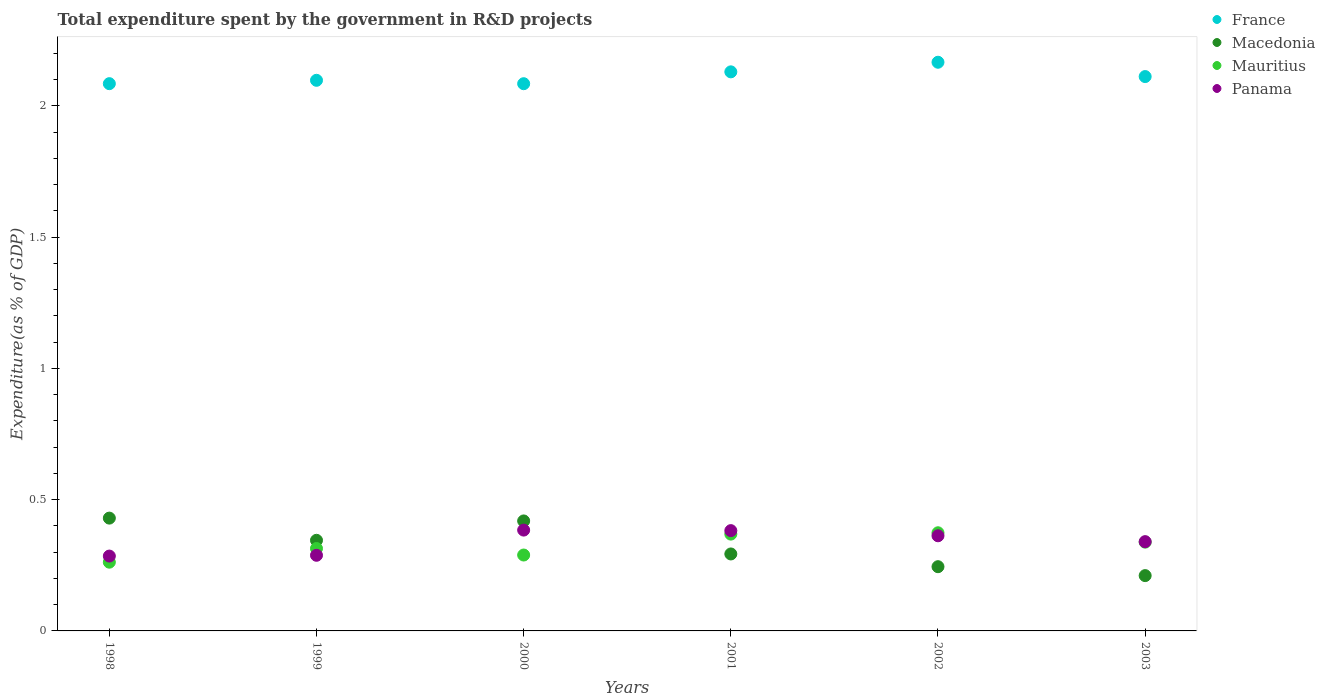How many different coloured dotlines are there?
Provide a short and direct response. 4. Is the number of dotlines equal to the number of legend labels?
Offer a terse response. Yes. What is the total expenditure spent by the government in R&D projects in Macedonia in 1999?
Provide a succinct answer. 0.35. Across all years, what is the maximum total expenditure spent by the government in R&D projects in France?
Give a very brief answer. 2.17. Across all years, what is the minimum total expenditure spent by the government in R&D projects in Panama?
Offer a very short reply. 0.29. What is the total total expenditure spent by the government in R&D projects in Panama in the graph?
Your response must be concise. 2.04. What is the difference between the total expenditure spent by the government in R&D projects in Mauritius in 2000 and that in 2001?
Keep it short and to the point. -0.08. What is the difference between the total expenditure spent by the government in R&D projects in Macedonia in 1998 and the total expenditure spent by the government in R&D projects in Panama in 2000?
Provide a short and direct response. 0.05. What is the average total expenditure spent by the government in R&D projects in France per year?
Your answer should be very brief. 2.11. In the year 2000, what is the difference between the total expenditure spent by the government in R&D projects in France and total expenditure spent by the government in R&D projects in Macedonia?
Keep it short and to the point. 1.67. In how many years, is the total expenditure spent by the government in R&D projects in France greater than 0.30000000000000004 %?
Keep it short and to the point. 6. What is the ratio of the total expenditure spent by the government in R&D projects in France in 1999 to that in 2000?
Your answer should be very brief. 1.01. Is the difference between the total expenditure spent by the government in R&D projects in France in 1999 and 2002 greater than the difference between the total expenditure spent by the government in R&D projects in Macedonia in 1999 and 2002?
Keep it short and to the point. No. What is the difference between the highest and the second highest total expenditure spent by the government in R&D projects in Macedonia?
Your answer should be very brief. 0.01. What is the difference between the highest and the lowest total expenditure spent by the government in R&D projects in Panama?
Make the answer very short. 0.1. In how many years, is the total expenditure spent by the government in R&D projects in Mauritius greater than the average total expenditure spent by the government in R&D projects in Mauritius taken over all years?
Your answer should be compact. 3. Is it the case that in every year, the sum of the total expenditure spent by the government in R&D projects in Macedonia and total expenditure spent by the government in R&D projects in Mauritius  is greater than the sum of total expenditure spent by the government in R&D projects in France and total expenditure spent by the government in R&D projects in Panama?
Make the answer very short. No. Is it the case that in every year, the sum of the total expenditure spent by the government in R&D projects in Mauritius and total expenditure spent by the government in R&D projects in Macedonia  is greater than the total expenditure spent by the government in R&D projects in Panama?
Give a very brief answer. Yes. Is the total expenditure spent by the government in R&D projects in France strictly greater than the total expenditure spent by the government in R&D projects in Panama over the years?
Ensure brevity in your answer.  Yes. How many years are there in the graph?
Your answer should be very brief. 6. Does the graph contain any zero values?
Make the answer very short. No. Does the graph contain grids?
Provide a succinct answer. No. Where does the legend appear in the graph?
Provide a succinct answer. Top right. How many legend labels are there?
Make the answer very short. 4. How are the legend labels stacked?
Ensure brevity in your answer.  Vertical. What is the title of the graph?
Make the answer very short. Total expenditure spent by the government in R&D projects. What is the label or title of the Y-axis?
Ensure brevity in your answer.  Expenditure(as % of GDP). What is the Expenditure(as % of GDP) of France in 1998?
Your response must be concise. 2.08. What is the Expenditure(as % of GDP) of Macedonia in 1998?
Your answer should be very brief. 0.43. What is the Expenditure(as % of GDP) in Mauritius in 1998?
Offer a very short reply. 0.26. What is the Expenditure(as % of GDP) of Panama in 1998?
Give a very brief answer. 0.29. What is the Expenditure(as % of GDP) in France in 1999?
Provide a succinct answer. 2.1. What is the Expenditure(as % of GDP) of Macedonia in 1999?
Your answer should be very brief. 0.35. What is the Expenditure(as % of GDP) of Mauritius in 1999?
Your answer should be very brief. 0.31. What is the Expenditure(as % of GDP) of Panama in 1999?
Offer a very short reply. 0.29. What is the Expenditure(as % of GDP) in France in 2000?
Your response must be concise. 2.08. What is the Expenditure(as % of GDP) of Macedonia in 2000?
Provide a succinct answer. 0.42. What is the Expenditure(as % of GDP) in Mauritius in 2000?
Provide a short and direct response. 0.29. What is the Expenditure(as % of GDP) in Panama in 2000?
Ensure brevity in your answer.  0.38. What is the Expenditure(as % of GDP) in France in 2001?
Your answer should be very brief. 2.13. What is the Expenditure(as % of GDP) in Macedonia in 2001?
Provide a succinct answer. 0.29. What is the Expenditure(as % of GDP) of Mauritius in 2001?
Your answer should be very brief. 0.37. What is the Expenditure(as % of GDP) in Panama in 2001?
Keep it short and to the point. 0.38. What is the Expenditure(as % of GDP) in France in 2002?
Provide a short and direct response. 2.17. What is the Expenditure(as % of GDP) of Macedonia in 2002?
Your response must be concise. 0.24. What is the Expenditure(as % of GDP) in Mauritius in 2002?
Ensure brevity in your answer.  0.37. What is the Expenditure(as % of GDP) of Panama in 2002?
Ensure brevity in your answer.  0.36. What is the Expenditure(as % of GDP) in France in 2003?
Give a very brief answer. 2.11. What is the Expenditure(as % of GDP) of Macedonia in 2003?
Your answer should be compact. 0.21. What is the Expenditure(as % of GDP) of Mauritius in 2003?
Provide a short and direct response. 0.34. What is the Expenditure(as % of GDP) in Panama in 2003?
Offer a terse response. 0.34. Across all years, what is the maximum Expenditure(as % of GDP) of France?
Your answer should be very brief. 2.17. Across all years, what is the maximum Expenditure(as % of GDP) in Macedonia?
Your response must be concise. 0.43. Across all years, what is the maximum Expenditure(as % of GDP) in Mauritius?
Your answer should be very brief. 0.37. Across all years, what is the maximum Expenditure(as % of GDP) of Panama?
Give a very brief answer. 0.38. Across all years, what is the minimum Expenditure(as % of GDP) of France?
Your response must be concise. 2.08. Across all years, what is the minimum Expenditure(as % of GDP) of Macedonia?
Provide a succinct answer. 0.21. Across all years, what is the minimum Expenditure(as % of GDP) in Mauritius?
Provide a short and direct response. 0.26. Across all years, what is the minimum Expenditure(as % of GDP) in Panama?
Keep it short and to the point. 0.29. What is the total Expenditure(as % of GDP) in France in the graph?
Provide a short and direct response. 12.67. What is the total Expenditure(as % of GDP) of Macedonia in the graph?
Give a very brief answer. 1.94. What is the total Expenditure(as % of GDP) of Mauritius in the graph?
Offer a very short reply. 1.95. What is the total Expenditure(as % of GDP) in Panama in the graph?
Provide a short and direct response. 2.04. What is the difference between the Expenditure(as % of GDP) in France in 1998 and that in 1999?
Your response must be concise. -0.01. What is the difference between the Expenditure(as % of GDP) in Macedonia in 1998 and that in 1999?
Your response must be concise. 0.08. What is the difference between the Expenditure(as % of GDP) in Mauritius in 1998 and that in 1999?
Your answer should be very brief. -0.05. What is the difference between the Expenditure(as % of GDP) of Panama in 1998 and that in 1999?
Ensure brevity in your answer.  -0. What is the difference between the Expenditure(as % of GDP) of France in 1998 and that in 2000?
Ensure brevity in your answer.  0. What is the difference between the Expenditure(as % of GDP) in Macedonia in 1998 and that in 2000?
Make the answer very short. 0.01. What is the difference between the Expenditure(as % of GDP) in Mauritius in 1998 and that in 2000?
Keep it short and to the point. -0.03. What is the difference between the Expenditure(as % of GDP) in Panama in 1998 and that in 2000?
Keep it short and to the point. -0.1. What is the difference between the Expenditure(as % of GDP) of France in 1998 and that in 2001?
Provide a short and direct response. -0.04. What is the difference between the Expenditure(as % of GDP) in Macedonia in 1998 and that in 2001?
Make the answer very short. 0.14. What is the difference between the Expenditure(as % of GDP) of Mauritius in 1998 and that in 2001?
Your answer should be very brief. -0.11. What is the difference between the Expenditure(as % of GDP) in Panama in 1998 and that in 2001?
Ensure brevity in your answer.  -0.1. What is the difference between the Expenditure(as % of GDP) of France in 1998 and that in 2002?
Provide a succinct answer. -0.08. What is the difference between the Expenditure(as % of GDP) in Macedonia in 1998 and that in 2002?
Your answer should be very brief. 0.18. What is the difference between the Expenditure(as % of GDP) in Mauritius in 1998 and that in 2002?
Offer a very short reply. -0.11. What is the difference between the Expenditure(as % of GDP) in Panama in 1998 and that in 2002?
Your response must be concise. -0.08. What is the difference between the Expenditure(as % of GDP) in France in 1998 and that in 2003?
Provide a short and direct response. -0.03. What is the difference between the Expenditure(as % of GDP) in Macedonia in 1998 and that in 2003?
Your answer should be very brief. 0.22. What is the difference between the Expenditure(as % of GDP) of Mauritius in 1998 and that in 2003?
Your response must be concise. -0.08. What is the difference between the Expenditure(as % of GDP) of Panama in 1998 and that in 2003?
Give a very brief answer. -0.05. What is the difference between the Expenditure(as % of GDP) in France in 1999 and that in 2000?
Your response must be concise. 0.01. What is the difference between the Expenditure(as % of GDP) of Macedonia in 1999 and that in 2000?
Give a very brief answer. -0.07. What is the difference between the Expenditure(as % of GDP) in Mauritius in 1999 and that in 2000?
Your answer should be compact. 0.02. What is the difference between the Expenditure(as % of GDP) of Panama in 1999 and that in 2000?
Keep it short and to the point. -0.1. What is the difference between the Expenditure(as % of GDP) in France in 1999 and that in 2001?
Your answer should be compact. -0.03. What is the difference between the Expenditure(as % of GDP) in Macedonia in 1999 and that in 2001?
Your response must be concise. 0.05. What is the difference between the Expenditure(as % of GDP) of Mauritius in 1999 and that in 2001?
Provide a short and direct response. -0.05. What is the difference between the Expenditure(as % of GDP) in Panama in 1999 and that in 2001?
Keep it short and to the point. -0.09. What is the difference between the Expenditure(as % of GDP) in France in 1999 and that in 2002?
Give a very brief answer. -0.07. What is the difference between the Expenditure(as % of GDP) of Macedonia in 1999 and that in 2002?
Your response must be concise. 0.1. What is the difference between the Expenditure(as % of GDP) in Mauritius in 1999 and that in 2002?
Give a very brief answer. -0.06. What is the difference between the Expenditure(as % of GDP) of Panama in 1999 and that in 2002?
Offer a terse response. -0.07. What is the difference between the Expenditure(as % of GDP) in France in 1999 and that in 2003?
Provide a succinct answer. -0.01. What is the difference between the Expenditure(as % of GDP) of Macedonia in 1999 and that in 2003?
Ensure brevity in your answer.  0.13. What is the difference between the Expenditure(as % of GDP) of Mauritius in 1999 and that in 2003?
Your answer should be very brief. -0.02. What is the difference between the Expenditure(as % of GDP) of Panama in 1999 and that in 2003?
Make the answer very short. -0.05. What is the difference between the Expenditure(as % of GDP) in France in 2000 and that in 2001?
Provide a succinct answer. -0.05. What is the difference between the Expenditure(as % of GDP) of Macedonia in 2000 and that in 2001?
Ensure brevity in your answer.  0.13. What is the difference between the Expenditure(as % of GDP) of Mauritius in 2000 and that in 2001?
Make the answer very short. -0.08. What is the difference between the Expenditure(as % of GDP) of Panama in 2000 and that in 2001?
Provide a succinct answer. 0. What is the difference between the Expenditure(as % of GDP) of France in 2000 and that in 2002?
Your answer should be very brief. -0.08. What is the difference between the Expenditure(as % of GDP) of Macedonia in 2000 and that in 2002?
Provide a succinct answer. 0.17. What is the difference between the Expenditure(as % of GDP) in Mauritius in 2000 and that in 2002?
Your answer should be very brief. -0.08. What is the difference between the Expenditure(as % of GDP) in Panama in 2000 and that in 2002?
Offer a very short reply. 0.02. What is the difference between the Expenditure(as % of GDP) of France in 2000 and that in 2003?
Offer a terse response. -0.03. What is the difference between the Expenditure(as % of GDP) of Macedonia in 2000 and that in 2003?
Your response must be concise. 0.21. What is the difference between the Expenditure(as % of GDP) of Mauritius in 2000 and that in 2003?
Give a very brief answer. -0.05. What is the difference between the Expenditure(as % of GDP) of Panama in 2000 and that in 2003?
Ensure brevity in your answer.  0.04. What is the difference between the Expenditure(as % of GDP) of France in 2001 and that in 2002?
Provide a short and direct response. -0.04. What is the difference between the Expenditure(as % of GDP) in Macedonia in 2001 and that in 2002?
Offer a very short reply. 0.05. What is the difference between the Expenditure(as % of GDP) of Mauritius in 2001 and that in 2002?
Offer a very short reply. -0.01. What is the difference between the Expenditure(as % of GDP) of Panama in 2001 and that in 2002?
Your answer should be compact. 0.02. What is the difference between the Expenditure(as % of GDP) in France in 2001 and that in 2003?
Give a very brief answer. 0.02. What is the difference between the Expenditure(as % of GDP) of Macedonia in 2001 and that in 2003?
Provide a succinct answer. 0.08. What is the difference between the Expenditure(as % of GDP) of Mauritius in 2001 and that in 2003?
Offer a terse response. 0.03. What is the difference between the Expenditure(as % of GDP) of Panama in 2001 and that in 2003?
Provide a short and direct response. 0.04. What is the difference between the Expenditure(as % of GDP) in France in 2002 and that in 2003?
Make the answer very short. 0.05. What is the difference between the Expenditure(as % of GDP) of Macedonia in 2002 and that in 2003?
Keep it short and to the point. 0.03. What is the difference between the Expenditure(as % of GDP) in Mauritius in 2002 and that in 2003?
Your answer should be very brief. 0.04. What is the difference between the Expenditure(as % of GDP) of Panama in 2002 and that in 2003?
Ensure brevity in your answer.  0.02. What is the difference between the Expenditure(as % of GDP) of France in 1998 and the Expenditure(as % of GDP) of Macedonia in 1999?
Keep it short and to the point. 1.74. What is the difference between the Expenditure(as % of GDP) of France in 1998 and the Expenditure(as % of GDP) of Mauritius in 1999?
Provide a short and direct response. 1.77. What is the difference between the Expenditure(as % of GDP) in France in 1998 and the Expenditure(as % of GDP) in Panama in 1999?
Offer a very short reply. 1.8. What is the difference between the Expenditure(as % of GDP) of Macedonia in 1998 and the Expenditure(as % of GDP) of Mauritius in 1999?
Your answer should be very brief. 0.12. What is the difference between the Expenditure(as % of GDP) in Macedonia in 1998 and the Expenditure(as % of GDP) in Panama in 1999?
Your answer should be compact. 0.14. What is the difference between the Expenditure(as % of GDP) in Mauritius in 1998 and the Expenditure(as % of GDP) in Panama in 1999?
Provide a succinct answer. -0.03. What is the difference between the Expenditure(as % of GDP) of France in 1998 and the Expenditure(as % of GDP) of Macedonia in 2000?
Keep it short and to the point. 1.67. What is the difference between the Expenditure(as % of GDP) of France in 1998 and the Expenditure(as % of GDP) of Mauritius in 2000?
Ensure brevity in your answer.  1.8. What is the difference between the Expenditure(as % of GDP) of France in 1998 and the Expenditure(as % of GDP) of Panama in 2000?
Your answer should be very brief. 1.7. What is the difference between the Expenditure(as % of GDP) of Macedonia in 1998 and the Expenditure(as % of GDP) of Mauritius in 2000?
Your response must be concise. 0.14. What is the difference between the Expenditure(as % of GDP) in Macedonia in 1998 and the Expenditure(as % of GDP) in Panama in 2000?
Your response must be concise. 0.05. What is the difference between the Expenditure(as % of GDP) in Mauritius in 1998 and the Expenditure(as % of GDP) in Panama in 2000?
Your answer should be compact. -0.12. What is the difference between the Expenditure(as % of GDP) in France in 1998 and the Expenditure(as % of GDP) in Macedonia in 2001?
Keep it short and to the point. 1.79. What is the difference between the Expenditure(as % of GDP) in France in 1998 and the Expenditure(as % of GDP) in Mauritius in 2001?
Ensure brevity in your answer.  1.72. What is the difference between the Expenditure(as % of GDP) in France in 1998 and the Expenditure(as % of GDP) in Panama in 2001?
Offer a very short reply. 1.7. What is the difference between the Expenditure(as % of GDP) of Macedonia in 1998 and the Expenditure(as % of GDP) of Mauritius in 2001?
Provide a short and direct response. 0.06. What is the difference between the Expenditure(as % of GDP) of Macedonia in 1998 and the Expenditure(as % of GDP) of Panama in 2001?
Your answer should be very brief. 0.05. What is the difference between the Expenditure(as % of GDP) of Mauritius in 1998 and the Expenditure(as % of GDP) of Panama in 2001?
Your answer should be compact. -0.12. What is the difference between the Expenditure(as % of GDP) of France in 1998 and the Expenditure(as % of GDP) of Macedonia in 2002?
Keep it short and to the point. 1.84. What is the difference between the Expenditure(as % of GDP) of France in 1998 and the Expenditure(as % of GDP) of Mauritius in 2002?
Your answer should be very brief. 1.71. What is the difference between the Expenditure(as % of GDP) in France in 1998 and the Expenditure(as % of GDP) in Panama in 2002?
Offer a very short reply. 1.72. What is the difference between the Expenditure(as % of GDP) in Macedonia in 1998 and the Expenditure(as % of GDP) in Mauritius in 2002?
Your answer should be very brief. 0.06. What is the difference between the Expenditure(as % of GDP) in Macedonia in 1998 and the Expenditure(as % of GDP) in Panama in 2002?
Provide a short and direct response. 0.07. What is the difference between the Expenditure(as % of GDP) in Mauritius in 1998 and the Expenditure(as % of GDP) in Panama in 2002?
Offer a terse response. -0.1. What is the difference between the Expenditure(as % of GDP) of France in 1998 and the Expenditure(as % of GDP) of Macedonia in 2003?
Offer a very short reply. 1.87. What is the difference between the Expenditure(as % of GDP) of France in 1998 and the Expenditure(as % of GDP) of Mauritius in 2003?
Give a very brief answer. 1.75. What is the difference between the Expenditure(as % of GDP) in France in 1998 and the Expenditure(as % of GDP) in Panama in 2003?
Provide a short and direct response. 1.74. What is the difference between the Expenditure(as % of GDP) in Macedonia in 1998 and the Expenditure(as % of GDP) in Mauritius in 2003?
Offer a terse response. 0.09. What is the difference between the Expenditure(as % of GDP) in Macedonia in 1998 and the Expenditure(as % of GDP) in Panama in 2003?
Your response must be concise. 0.09. What is the difference between the Expenditure(as % of GDP) in Mauritius in 1998 and the Expenditure(as % of GDP) in Panama in 2003?
Give a very brief answer. -0.08. What is the difference between the Expenditure(as % of GDP) in France in 1999 and the Expenditure(as % of GDP) in Macedonia in 2000?
Ensure brevity in your answer.  1.68. What is the difference between the Expenditure(as % of GDP) of France in 1999 and the Expenditure(as % of GDP) of Mauritius in 2000?
Ensure brevity in your answer.  1.81. What is the difference between the Expenditure(as % of GDP) in France in 1999 and the Expenditure(as % of GDP) in Panama in 2000?
Give a very brief answer. 1.71. What is the difference between the Expenditure(as % of GDP) of Macedonia in 1999 and the Expenditure(as % of GDP) of Mauritius in 2000?
Offer a very short reply. 0.06. What is the difference between the Expenditure(as % of GDP) in Macedonia in 1999 and the Expenditure(as % of GDP) in Panama in 2000?
Give a very brief answer. -0.04. What is the difference between the Expenditure(as % of GDP) of Mauritius in 1999 and the Expenditure(as % of GDP) of Panama in 2000?
Offer a very short reply. -0.07. What is the difference between the Expenditure(as % of GDP) of France in 1999 and the Expenditure(as % of GDP) of Macedonia in 2001?
Offer a terse response. 1.8. What is the difference between the Expenditure(as % of GDP) in France in 1999 and the Expenditure(as % of GDP) in Mauritius in 2001?
Keep it short and to the point. 1.73. What is the difference between the Expenditure(as % of GDP) in France in 1999 and the Expenditure(as % of GDP) in Panama in 2001?
Give a very brief answer. 1.72. What is the difference between the Expenditure(as % of GDP) of Macedonia in 1999 and the Expenditure(as % of GDP) of Mauritius in 2001?
Offer a terse response. -0.02. What is the difference between the Expenditure(as % of GDP) in Macedonia in 1999 and the Expenditure(as % of GDP) in Panama in 2001?
Ensure brevity in your answer.  -0.04. What is the difference between the Expenditure(as % of GDP) in Mauritius in 1999 and the Expenditure(as % of GDP) in Panama in 2001?
Give a very brief answer. -0.07. What is the difference between the Expenditure(as % of GDP) of France in 1999 and the Expenditure(as % of GDP) of Macedonia in 2002?
Your response must be concise. 1.85. What is the difference between the Expenditure(as % of GDP) in France in 1999 and the Expenditure(as % of GDP) in Mauritius in 2002?
Make the answer very short. 1.72. What is the difference between the Expenditure(as % of GDP) of France in 1999 and the Expenditure(as % of GDP) of Panama in 2002?
Your response must be concise. 1.73. What is the difference between the Expenditure(as % of GDP) of Macedonia in 1999 and the Expenditure(as % of GDP) of Mauritius in 2002?
Your response must be concise. -0.03. What is the difference between the Expenditure(as % of GDP) of Macedonia in 1999 and the Expenditure(as % of GDP) of Panama in 2002?
Your answer should be compact. -0.02. What is the difference between the Expenditure(as % of GDP) of Mauritius in 1999 and the Expenditure(as % of GDP) of Panama in 2002?
Provide a succinct answer. -0.05. What is the difference between the Expenditure(as % of GDP) in France in 1999 and the Expenditure(as % of GDP) in Macedonia in 2003?
Keep it short and to the point. 1.89. What is the difference between the Expenditure(as % of GDP) in France in 1999 and the Expenditure(as % of GDP) in Mauritius in 2003?
Give a very brief answer. 1.76. What is the difference between the Expenditure(as % of GDP) in France in 1999 and the Expenditure(as % of GDP) in Panama in 2003?
Offer a terse response. 1.76. What is the difference between the Expenditure(as % of GDP) of Macedonia in 1999 and the Expenditure(as % of GDP) of Mauritius in 2003?
Your answer should be compact. 0.01. What is the difference between the Expenditure(as % of GDP) of Macedonia in 1999 and the Expenditure(as % of GDP) of Panama in 2003?
Give a very brief answer. 0.01. What is the difference between the Expenditure(as % of GDP) in Mauritius in 1999 and the Expenditure(as % of GDP) in Panama in 2003?
Provide a succinct answer. -0.03. What is the difference between the Expenditure(as % of GDP) in France in 2000 and the Expenditure(as % of GDP) in Macedonia in 2001?
Offer a very short reply. 1.79. What is the difference between the Expenditure(as % of GDP) of France in 2000 and the Expenditure(as % of GDP) of Mauritius in 2001?
Your answer should be compact. 1.72. What is the difference between the Expenditure(as % of GDP) in France in 2000 and the Expenditure(as % of GDP) in Panama in 2001?
Give a very brief answer. 1.7. What is the difference between the Expenditure(as % of GDP) in Macedonia in 2000 and the Expenditure(as % of GDP) in Mauritius in 2001?
Provide a short and direct response. 0.05. What is the difference between the Expenditure(as % of GDP) of Macedonia in 2000 and the Expenditure(as % of GDP) of Panama in 2001?
Provide a short and direct response. 0.04. What is the difference between the Expenditure(as % of GDP) of Mauritius in 2000 and the Expenditure(as % of GDP) of Panama in 2001?
Your answer should be very brief. -0.09. What is the difference between the Expenditure(as % of GDP) in France in 2000 and the Expenditure(as % of GDP) in Macedonia in 2002?
Keep it short and to the point. 1.84. What is the difference between the Expenditure(as % of GDP) of France in 2000 and the Expenditure(as % of GDP) of Mauritius in 2002?
Ensure brevity in your answer.  1.71. What is the difference between the Expenditure(as % of GDP) of France in 2000 and the Expenditure(as % of GDP) of Panama in 2002?
Provide a short and direct response. 1.72. What is the difference between the Expenditure(as % of GDP) of Macedonia in 2000 and the Expenditure(as % of GDP) of Mauritius in 2002?
Give a very brief answer. 0.05. What is the difference between the Expenditure(as % of GDP) in Macedonia in 2000 and the Expenditure(as % of GDP) in Panama in 2002?
Keep it short and to the point. 0.06. What is the difference between the Expenditure(as % of GDP) in Mauritius in 2000 and the Expenditure(as % of GDP) in Panama in 2002?
Ensure brevity in your answer.  -0.07. What is the difference between the Expenditure(as % of GDP) in France in 2000 and the Expenditure(as % of GDP) in Macedonia in 2003?
Your answer should be very brief. 1.87. What is the difference between the Expenditure(as % of GDP) of France in 2000 and the Expenditure(as % of GDP) of Mauritius in 2003?
Offer a very short reply. 1.75. What is the difference between the Expenditure(as % of GDP) in France in 2000 and the Expenditure(as % of GDP) in Panama in 2003?
Ensure brevity in your answer.  1.74. What is the difference between the Expenditure(as % of GDP) of Macedonia in 2000 and the Expenditure(as % of GDP) of Mauritius in 2003?
Your response must be concise. 0.08. What is the difference between the Expenditure(as % of GDP) of Macedonia in 2000 and the Expenditure(as % of GDP) of Panama in 2003?
Provide a succinct answer. 0.08. What is the difference between the Expenditure(as % of GDP) of Mauritius in 2000 and the Expenditure(as % of GDP) of Panama in 2003?
Offer a very short reply. -0.05. What is the difference between the Expenditure(as % of GDP) in France in 2001 and the Expenditure(as % of GDP) in Macedonia in 2002?
Your answer should be very brief. 1.88. What is the difference between the Expenditure(as % of GDP) of France in 2001 and the Expenditure(as % of GDP) of Mauritius in 2002?
Ensure brevity in your answer.  1.76. What is the difference between the Expenditure(as % of GDP) of France in 2001 and the Expenditure(as % of GDP) of Panama in 2002?
Ensure brevity in your answer.  1.77. What is the difference between the Expenditure(as % of GDP) of Macedonia in 2001 and the Expenditure(as % of GDP) of Mauritius in 2002?
Your answer should be compact. -0.08. What is the difference between the Expenditure(as % of GDP) in Macedonia in 2001 and the Expenditure(as % of GDP) in Panama in 2002?
Provide a short and direct response. -0.07. What is the difference between the Expenditure(as % of GDP) of Mauritius in 2001 and the Expenditure(as % of GDP) of Panama in 2002?
Ensure brevity in your answer.  0.01. What is the difference between the Expenditure(as % of GDP) in France in 2001 and the Expenditure(as % of GDP) in Macedonia in 2003?
Offer a very short reply. 1.92. What is the difference between the Expenditure(as % of GDP) in France in 2001 and the Expenditure(as % of GDP) in Mauritius in 2003?
Keep it short and to the point. 1.79. What is the difference between the Expenditure(as % of GDP) in France in 2001 and the Expenditure(as % of GDP) in Panama in 2003?
Keep it short and to the point. 1.79. What is the difference between the Expenditure(as % of GDP) of Macedonia in 2001 and the Expenditure(as % of GDP) of Mauritius in 2003?
Keep it short and to the point. -0.04. What is the difference between the Expenditure(as % of GDP) in Macedonia in 2001 and the Expenditure(as % of GDP) in Panama in 2003?
Offer a very short reply. -0.05. What is the difference between the Expenditure(as % of GDP) of Mauritius in 2001 and the Expenditure(as % of GDP) of Panama in 2003?
Ensure brevity in your answer.  0.03. What is the difference between the Expenditure(as % of GDP) in France in 2002 and the Expenditure(as % of GDP) in Macedonia in 2003?
Keep it short and to the point. 1.96. What is the difference between the Expenditure(as % of GDP) of France in 2002 and the Expenditure(as % of GDP) of Mauritius in 2003?
Your response must be concise. 1.83. What is the difference between the Expenditure(as % of GDP) of France in 2002 and the Expenditure(as % of GDP) of Panama in 2003?
Your answer should be compact. 1.83. What is the difference between the Expenditure(as % of GDP) in Macedonia in 2002 and the Expenditure(as % of GDP) in Mauritius in 2003?
Provide a short and direct response. -0.09. What is the difference between the Expenditure(as % of GDP) of Macedonia in 2002 and the Expenditure(as % of GDP) of Panama in 2003?
Give a very brief answer. -0.1. What is the difference between the Expenditure(as % of GDP) of Mauritius in 2002 and the Expenditure(as % of GDP) of Panama in 2003?
Give a very brief answer. 0.03. What is the average Expenditure(as % of GDP) in France per year?
Your response must be concise. 2.11. What is the average Expenditure(as % of GDP) in Macedonia per year?
Your answer should be compact. 0.32. What is the average Expenditure(as % of GDP) in Mauritius per year?
Ensure brevity in your answer.  0.32. What is the average Expenditure(as % of GDP) of Panama per year?
Give a very brief answer. 0.34. In the year 1998, what is the difference between the Expenditure(as % of GDP) in France and Expenditure(as % of GDP) in Macedonia?
Ensure brevity in your answer.  1.65. In the year 1998, what is the difference between the Expenditure(as % of GDP) of France and Expenditure(as % of GDP) of Mauritius?
Offer a very short reply. 1.82. In the year 1998, what is the difference between the Expenditure(as % of GDP) in France and Expenditure(as % of GDP) in Panama?
Offer a terse response. 1.8. In the year 1998, what is the difference between the Expenditure(as % of GDP) in Macedonia and Expenditure(as % of GDP) in Mauritius?
Give a very brief answer. 0.17. In the year 1998, what is the difference between the Expenditure(as % of GDP) in Macedonia and Expenditure(as % of GDP) in Panama?
Offer a very short reply. 0.14. In the year 1998, what is the difference between the Expenditure(as % of GDP) of Mauritius and Expenditure(as % of GDP) of Panama?
Ensure brevity in your answer.  -0.02. In the year 1999, what is the difference between the Expenditure(as % of GDP) of France and Expenditure(as % of GDP) of Macedonia?
Provide a short and direct response. 1.75. In the year 1999, what is the difference between the Expenditure(as % of GDP) of France and Expenditure(as % of GDP) of Mauritius?
Your response must be concise. 1.78. In the year 1999, what is the difference between the Expenditure(as % of GDP) of France and Expenditure(as % of GDP) of Panama?
Give a very brief answer. 1.81. In the year 1999, what is the difference between the Expenditure(as % of GDP) in Macedonia and Expenditure(as % of GDP) in Mauritius?
Your answer should be very brief. 0.03. In the year 1999, what is the difference between the Expenditure(as % of GDP) in Macedonia and Expenditure(as % of GDP) in Panama?
Your answer should be compact. 0.06. In the year 1999, what is the difference between the Expenditure(as % of GDP) of Mauritius and Expenditure(as % of GDP) of Panama?
Ensure brevity in your answer.  0.03. In the year 2000, what is the difference between the Expenditure(as % of GDP) of France and Expenditure(as % of GDP) of Macedonia?
Make the answer very short. 1.67. In the year 2000, what is the difference between the Expenditure(as % of GDP) in France and Expenditure(as % of GDP) in Mauritius?
Offer a terse response. 1.79. In the year 2000, what is the difference between the Expenditure(as % of GDP) of Macedonia and Expenditure(as % of GDP) of Mauritius?
Ensure brevity in your answer.  0.13. In the year 2000, what is the difference between the Expenditure(as % of GDP) in Macedonia and Expenditure(as % of GDP) in Panama?
Provide a short and direct response. 0.03. In the year 2000, what is the difference between the Expenditure(as % of GDP) of Mauritius and Expenditure(as % of GDP) of Panama?
Offer a very short reply. -0.09. In the year 2001, what is the difference between the Expenditure(as % of GDP) of France and Expenditure(as % of GDP) of Macedonia?
Provide a succinct answer. 1.84. In the year 2001, what is the difference between the Expenditure(as % of GDP) in France and Expenditure(as % of GDP) in Mauritius?
Your answer should be very brief. 1.76. In the year 2001, what is the difference between the Expenditure(as % of GDP) of France and Expenditure(as % of GDP) of Panama?
Offer a terse response. 1.75. In the year 2001, what is the difference between the Expenditure(as % of GDP) in Macedonia and Expenditure(as % of GDP) in Mauritius?
Ensure brevity in your answer.  -0.08. In the year 2001, what is the difference between the Expenditure(as % of GDP) in Macedonia and Expenditure(as % of GDP) in Panama?
Make the answer very short. -0.09. In the year 2001, what is the difference between the Expenditure(as % of GDP) in Mauritius and Expenditure(as % of GDP) in Panama?
Make the answer very short. -0.01. In the year 2002, what is the difference between the Expenditure(as % of GDP) in France and Expenditure(as % of GDP) in Macedonia?
Offer a terse response. 1.92. In the year 2002, what is the difference between the Expenditure(as % of GDP) of France and Expenditure(as % of GDP) of Mauritius?
Provide a short and direct response. 1.79. In the year 2002, what is the difference between the Expenditure(as % of GDP) in France and Expenditure(as % of GDP) in Panama?
Your response must be concise. 1.8. In the year 2002, what is the difference between the Expenditure(as % of GDP) in Macedonia and Expenditure(as % of GDP) in Mauritius?
Offer a terse response. -0.13. In the year 2002, what is the difference between the Expenditure(as % of GDP) of Macedonia and Expenditure(as % of GDP) of Panama?
Your answer should be compact. -0.12. In the year 2002, what is the difference between the Expenditure(as % of GDP) of Mauritius and Expenditure(as % of GDP) of Panama?
Your answer should be very brief. 0.01. In the year 2003, what is the difference between the Expenditure(as % of GDP) of France and Expenditure(as % of GDP) of Macedonia?
Ensure brevity in your answer.  1.9. In the year 2003, what is the difference between the Expenditure(as % of GDP) of France and Expenditure(as % of GDP) of Mauritius?
Offer a terse response. 1.77. In the year 2003, what is the difference between the Expenditure(as % of GDP) in France and Expenditure(as % of GDP) in Panama?
Offer a very short reply. 1.77. In the year 2003, what is the difference between the Expenditure(as % of GDP) of Macedonia and Expenditure(as % of GDP) of Mauritius?
Your response must be concise. -0.13. In the year 2003, what is the difference between the Expenditure(as % of GDP) in Macedonia and Expenditure(as % of GDP) in Panama?
Your answer should be compact. -0.13. In the year 2003, what is the difference between the Expenditure(as % of GDP) of Mauritius and Expenditure(as % of GDP) of Panama?
Offer a very short reply. -0. What is the ratio of the Expenditure(as % of GDP) in France in 1998 to that in 1999?
Ensure brevity in your answer.  0.99. What is the ratio of the Expenditure(as % of GDP) in Macedonia in 1998 to that in 1999?
Your response must be concise. 1.24. What is the ratio of the Expenditure(as % of GDP) in Mauritius in 1998 to that in 1999?
Your response must be concise. 0.83. What is the ratio of the Expenditure(as % of GDP) of France in 1998 to that in 2000?
Offer a very short reply. 1. What is the ratio of the Expenditure(as % of GDP) of Macedonia in 1998 to that in 2000?
Ensure brevity in your answer.  1.03. What is the ratio of the Expenditure(as % of GDP) of Mauritius in 1998 to that in 2000?
Your answer should be compact. 0.91. What is the ratio of the Expenditure(as % of GDP) in Panama in 1998 to that in 2000?
Make the answer very short. 0.74. What is the ratio of the Expenditure(as % of GDP) of France in 1998 to that in 2001?
Provide a succinct answer. 0.98. What is the ratio of the Expenditure(as % of GDP) of Macedonia in 1998 to that in 2001?
Provide a succinct answer. 1.47. What is the ratio of the Expenditure(as % of GDP) in Mauritius in 1998 to that in 2001?
Keep it short and to the point. 0.71. What is the ratio of the Expenditure(as % of GDP) of Panama in 1998 to that in 2001?
Your response must be concise. 0.75. What is the ratio of the Expenditure(as % of GDP) in France in 1998 to that in 2002?
Offer a terse response. 0.96. What is the ratio of the Expenditure(as % of GDP) of Macedonia in 1998 to that in 2002?
Give a very brief answer. 1.76. What is the ratio of the Expenditure(as % of GDP) in Mauritius in 1998 to that in 2002?
Offer a very short reply. 0.7. What is the ratio of the Expenditure(as % of GDP) in Panama in 1998 to that in 2002?
Keep it short and to the point. 0.79. What is the ratio of the Expenditure(as % of GDP) of France in 1998 to that in 2003?
Your response must be concise. 0.99. What is the ratio of the Expenditure(as % of GDP) of Macedonia in 1998 to that in 2003?
Provide a short and direct response. 2.04. What is the ratio of the Expenditure(as % of GDP) of Mauritius in 1998 to that in 2003?
Offer a very short reply. 0.77. What is the ratio of the Expenditure(as % of GDP) in Panama in 1998 to that in 2003?
Provide a short and direct response. 0.84. What is the ratio of the Expenditure(as % of GDP) in Macedonia in 1999 to that in 2000?
Offer a terse response. 0.82. What is the ratio of the Expenditure(as % of GDP) of Mauritius in 1999 to that in 2000?
Your answer should be compact. 1.09. What is the ratio of the Expenditure(as % of GDP) of Panama in 1999 to that in 2000?
Offer a terse response. 0.75. What is the ratio of the Expenditure(as % of GDP) of France in 1999 to that in 2001?
Your answer should be very brief. 0.98. What is the ratio of the Expenditure(as % of GDP) of Macedonia in 1999 to that in 2001?
Ensure brevity in your answer.  1.18. What is the ratio of the Expenditure(as % of GDP) in Mauritius in 1999 to that in 2001?
Ensure brevity in your answer.  0.85. What is the ratio of the Expenditure(as % of GDP) of Panama in 1999 to that in 2001?
Your response must be concise. 0.75. What is the ratio of the Expenditure(as % of GDP) of France in 1999 to that in 2002?
Ensure brevity in your answer.  0.97. What is the ratio of the Expenditure(as % of GDP) of Macedonia in 1999 to that in 2002?
Provide a succinct answer. 1.41. What is the ratio of the Expenditure(as % of GDP) in Mauritius in 1999 to that in 2002?
Offer a very short reply. 0.84. What is the ratio of the Expenditure(as % of GDP) of Panama in 1999 to that in 2002?
Provide a succinct answer. 0.8. What is the ratio of the Expenditure(as % of GDP) of France in 1999 to that in 2003?
Your answer should be very brief. 0.99. What is the ratio of the Expenditure(as % of GDP) in Macedonia in 1999 to that in 2003?
Offer a terse response. 1.64. What is the ratio of the Expenditure(as % of GDP) of Mauritius in 1999 to that in 2003?
Offer a terse response. 0.93. What is the ratio of the Expenditure(as % of GDP) in Panama in 1999 to that in 2003?
Your response must be concise. 0.85. What is the ratio of the Expenditure(as % of GDP) in France in 2000 to that in 2001?
Provide a succinct answer. 0.98. What is the ratio of the Expenditure(as % of GDP) of Macedonia in 2000 to that in 2001?
Offer a very short reply. 1.43. What is the ratio of the Expenditure(as % of GDP) of Mauritius in 2000 to that in 2001?
Your answer should be very brief. 0.78. What is the ratio of the Expenditure(as % of GDP) of Panama in 2000 to that in 2001?
Offer a terse response. 1.01. What is the ratio of the Expenditure(as % of GDP) in France in 2000 to that in 2002?
Keep it short and to the point. 0.96. What is the ratio of the Expenditure(as % of GDP) of Macedonia in 2000 to that in 2002?
Your answer should be very brief. 1.71. What is the ratio of the Expenditure(as % of GDP) of Mauritius in 2000 to that in 2002?
Offer a very short reply. 0.77. What is the ratio of the Expenditure(as % of GDP) in Panama in 2000 to that in 2002?
Your response must be concise. 1.06. What is the ratio of the Expenditure(as % of GDP) of France in 2000 to that in 2003?
Offer a very short reply. 0.99. What is the ratio of the Expenditure(as % of GDP) in Macedonia in 2000 to that in 2003?
Ensure brevity in your answer.  1.99. What is the ratio of the Expenditure(as % of GDP) of Mauritius in 2000 to that in 2003?
Offer a terse response. 0.85. What is the ratio of the Expenditure(as % of GDP) of Panama in 2000 to that in 2003?
Ensure brevity in your answer.  1.13. What is the ratio of the Expenditure(as % of GDP) of France in 2001 to that in 2002?
Provide a short and direct response. 0.98. What is the ratio of the Expenditure(as % of GDP) in Macedonia in 2001 to that in 2002?
Offer a terse response. 1.2. What is the ratio of the Expenditure(as % of GDP) of Mauritius in 2001 to that in 2002?
Provide a short and direct response. 0.99. What is the ratio of the Expenditure(as % of GDP) of Panama in 2001 to that in 2002?
Ensure brevity in your answer.  1.05. What is the ratio of the Expenditure(as % of GDP) of France in 2001 to that in 2003?
Provide a short and direct response. 1.01. What is the ratio of the Expenditure(as % of GDP) of Macedonia in 2001 to that in 2003?
Keep it short and to the point. 1.39. What is the ratio of the Expenditure(as % of GDP) of Mauritius in 2001 to that in 2003?
Your answer should be compact. 1.09. What is the ratio of the Expenditure(as % of GDP) in Panama in 2001 to that in 2003?
Offer a terse response. 1.12. What is the ratio of the Expenditure(as % of GDP) in France in 2002 to that in 2003?
Keep it short and to the point. 1.03. What is the ratio of the Expenditure(as % of GDP) of Macedonia in 2002 to that in 2003?
Offer a very short reply. 1.16. What is the ratio of the Expenditure(as % of GDP) in Mauritius in 2002 to that in 2003?
Your answer should be very brief. 1.11. What is the ratio of the Expenditure(as % of GDP) in Panama in 2002 to that in 2003?
Give a very brief answer. 1.07. What is the difference between the highest and the second highest Expenditure(as % of GDP) of France?
Give a very brief answer. 0.04. What is the difference between the highest and the second highest Expenditure(as % of GDP) of Macedonia?
Keep it short and to the point. 0.01. What is the difference between the highest and the second highest Expenditure(as % of GDP) of Mauritius?
Provide a succinct answer. 0.01. What is the difference between the highest and the second highest Expenditure(as % of GDP) of Panama?
Your response must be concise. 0. What is the difference between the highest and the lowest Expenditure(as % of GDP) in France?
Offer a terse response. 0.08. What is the difference between the highest and the lowest Expenditure(as % of GDP) in Macedonia?
Ensure brevity in your answer.  0.22. What is the difference between the highest and the lowest Expenditure(as % of GDP) in Mauritius?
Your answer should be very brief. 0.11. What is the difference between the highest and the lowest Expenditure(as % of GDP) of Panama?
Keep it short and to the point. 0.1. 